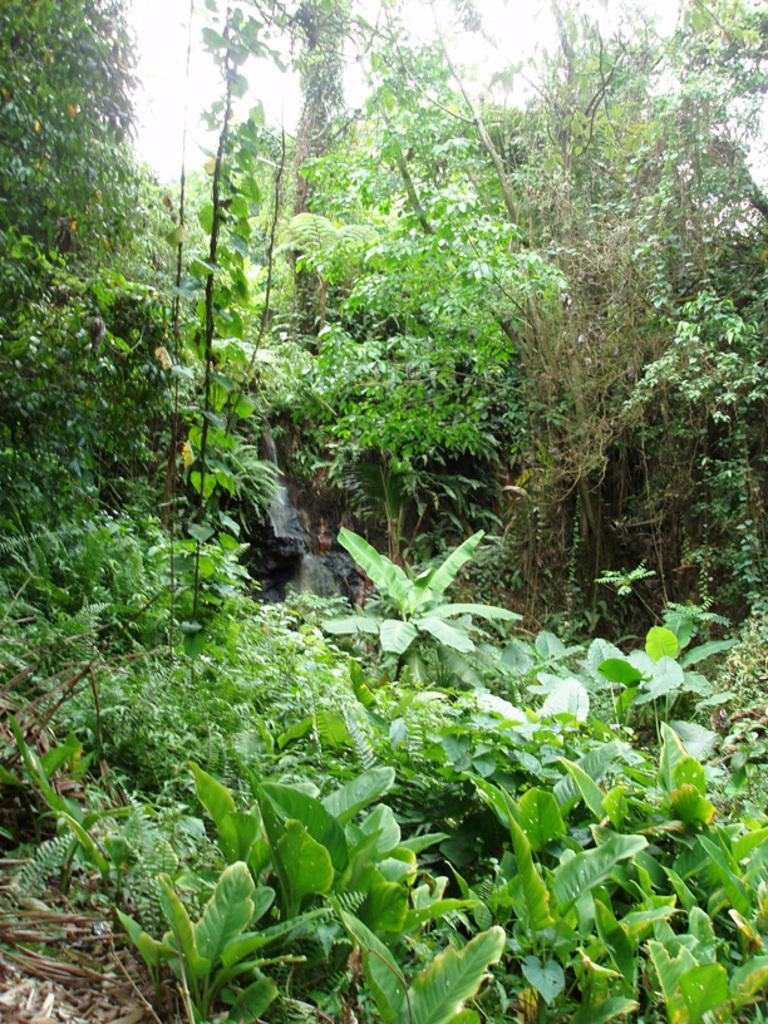Describe this image in one or two sentences. In this image we can see some group of trees, plants, dried leaves and the sky. 